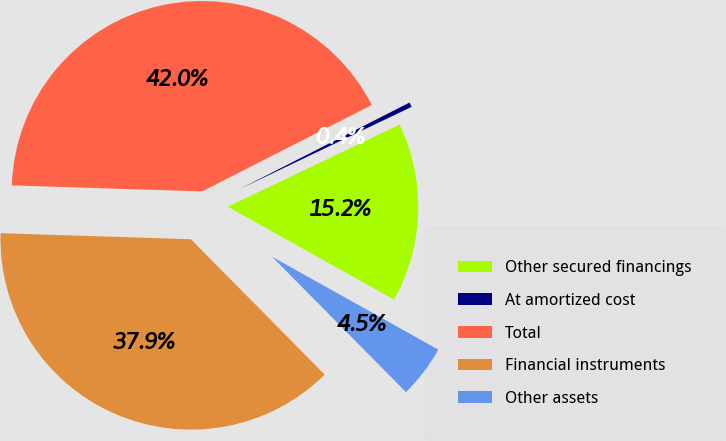<chart> <loc_0><loc_0><loc_500><loc_500><pie_chart><fcel>Other secured financings<fcel>At amortized cost<fcel>Total<fcel>Financial instruments<fcel>Other assets<nl><fcel>15.21%<fcel>0.4%<fcel>42.0%<fcel>37.91%<fcel>4.48%<nl></chart> 